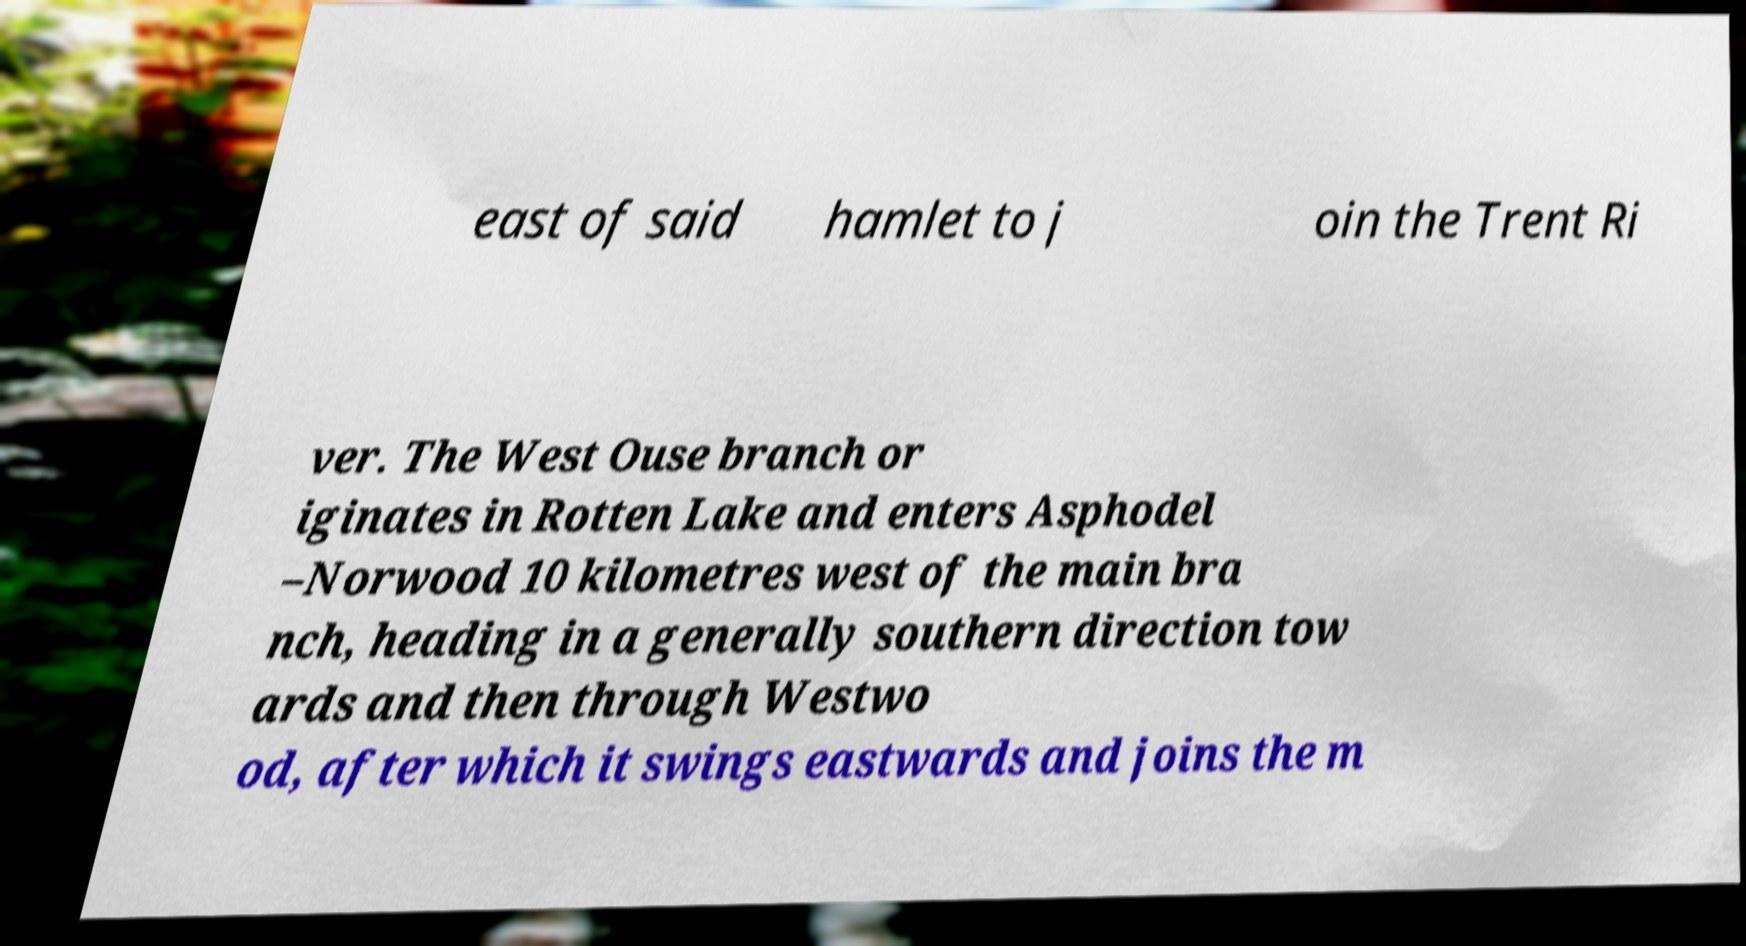Please identify and transcribe the text found in this image. east of said hamlet to j oin the Trent Ri ver. The West Ouse branch or iginates in Rotten Lake and enters Asphodel –Norwood 10 kilometres west of the main bra nch, heading in a generally southern direction tow ards and then through Westwo od, after which it swings eastwards and joins the m 